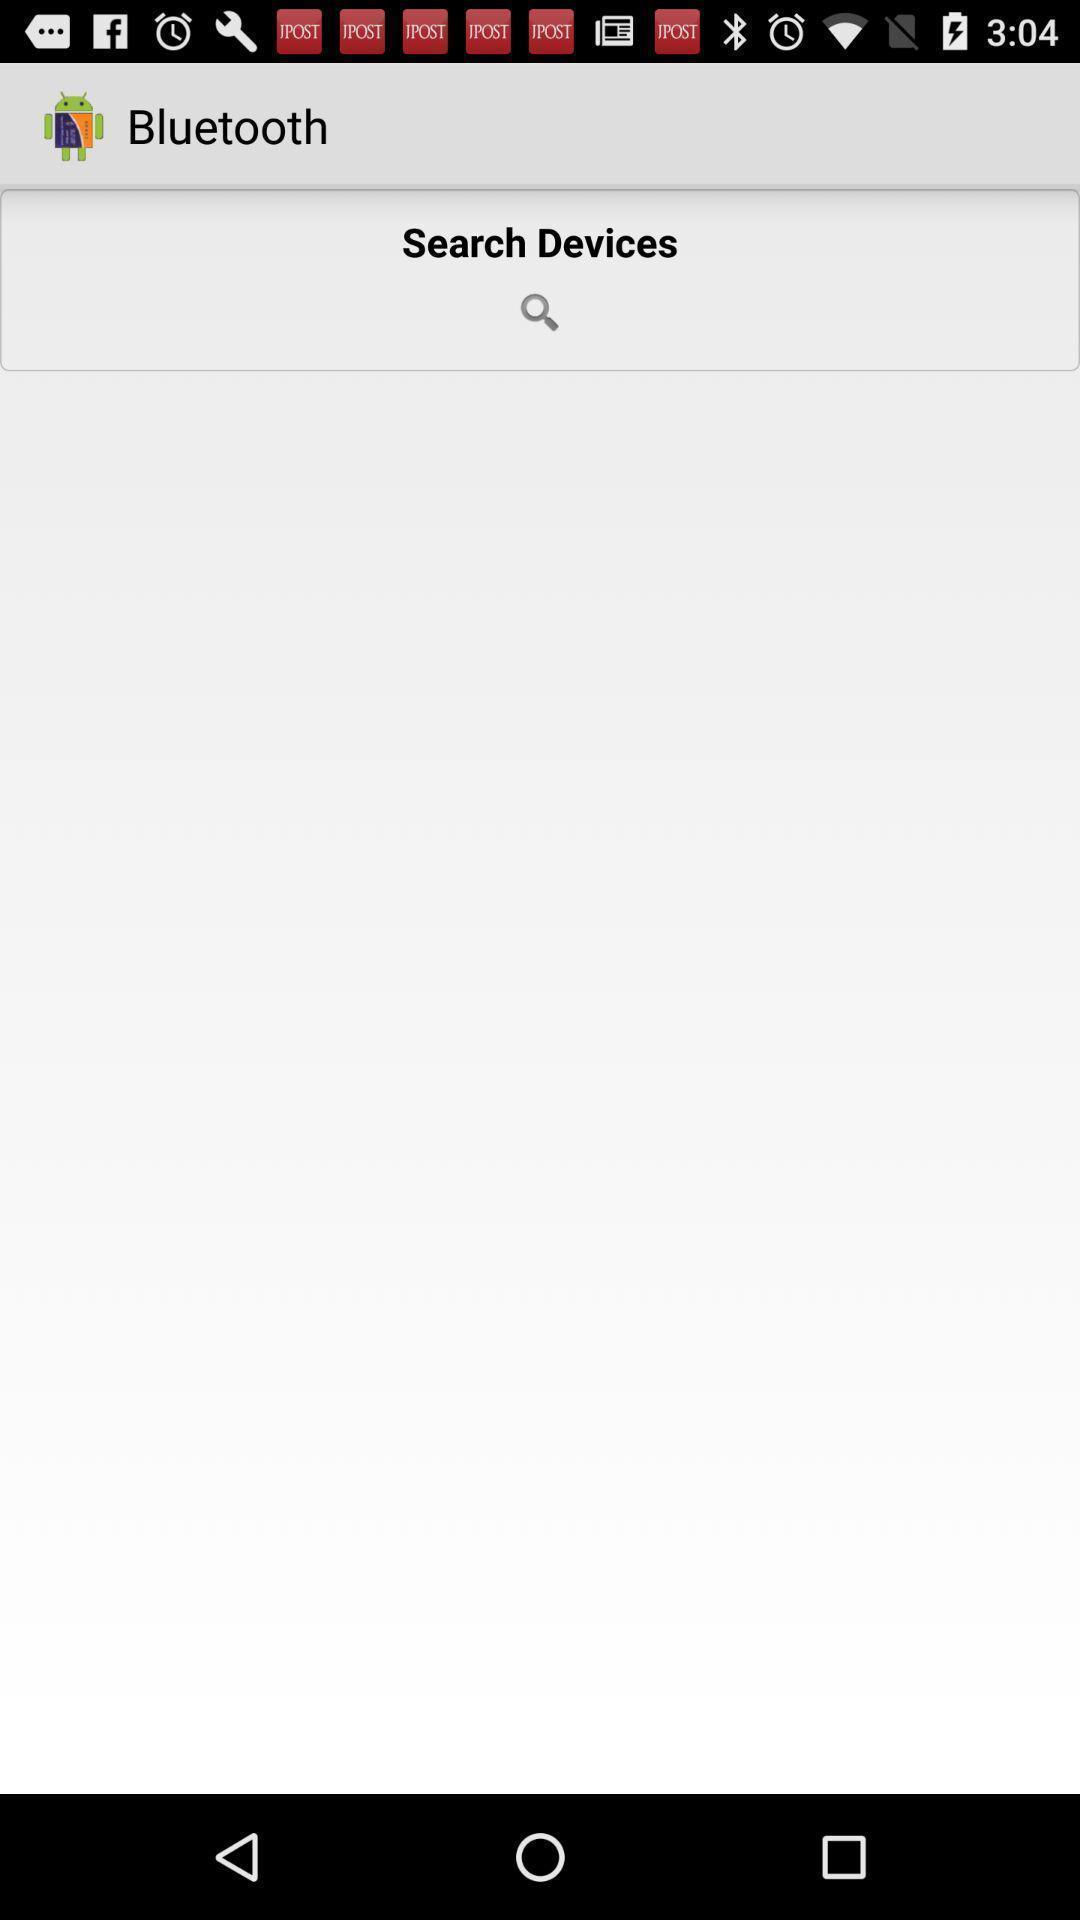Describe the content in this image. Window displaying a bluetooth page. 